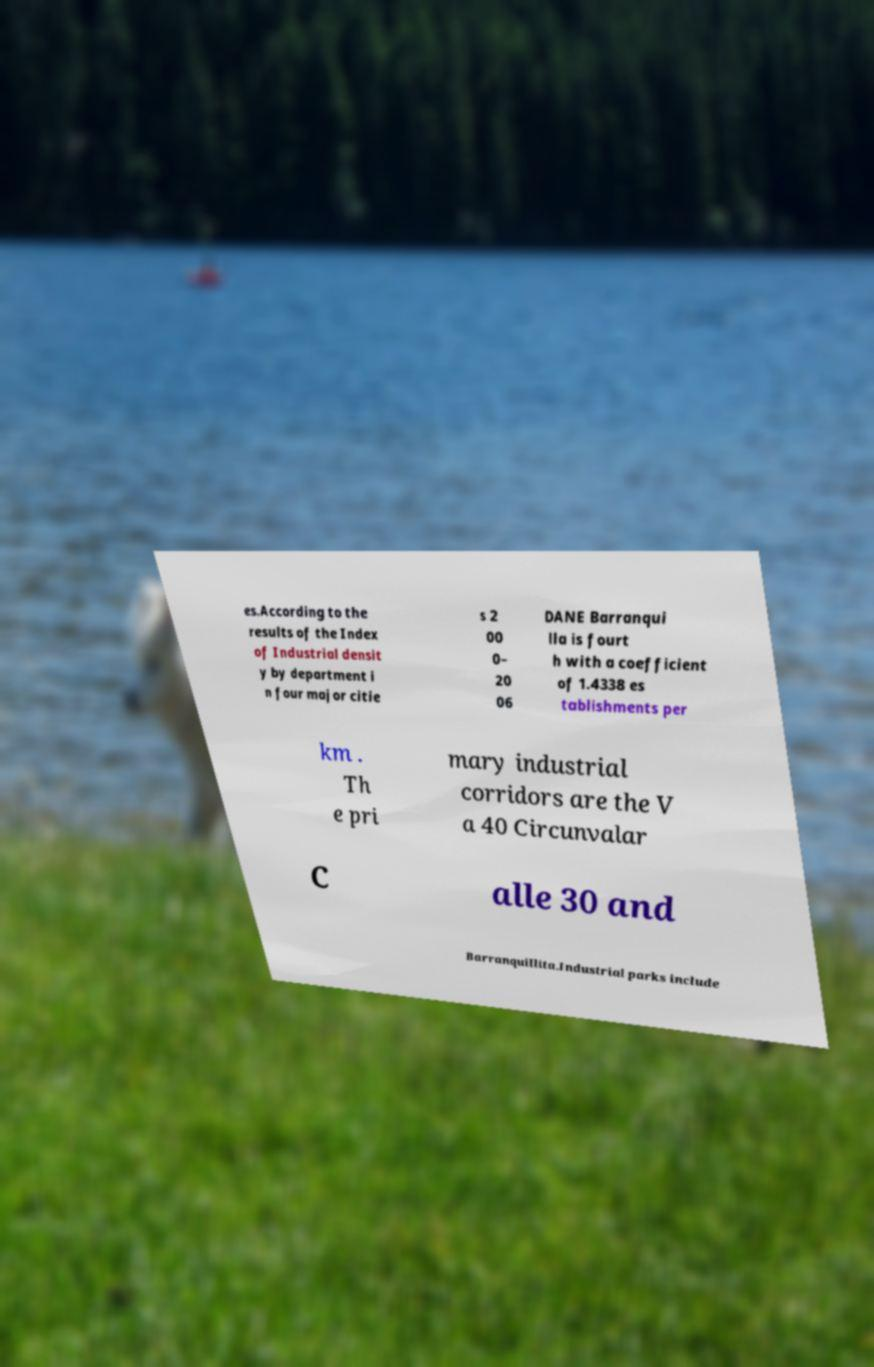Can you read and provide the text displayed in the image?This photo seems to have some interesting text. Can you extract and type it out for me? es.According to the results of the Index of Industrial densit y by department i n four major citie s 2 00 0– 20 06 DANE Barranqui lla is fourt h with a coefficient of 1.4338 es tablishments per km . Th e pri mary industrial corridors are the V a 40 Circunvalar C alle 30 and Barranquillita.Industrial parks include 